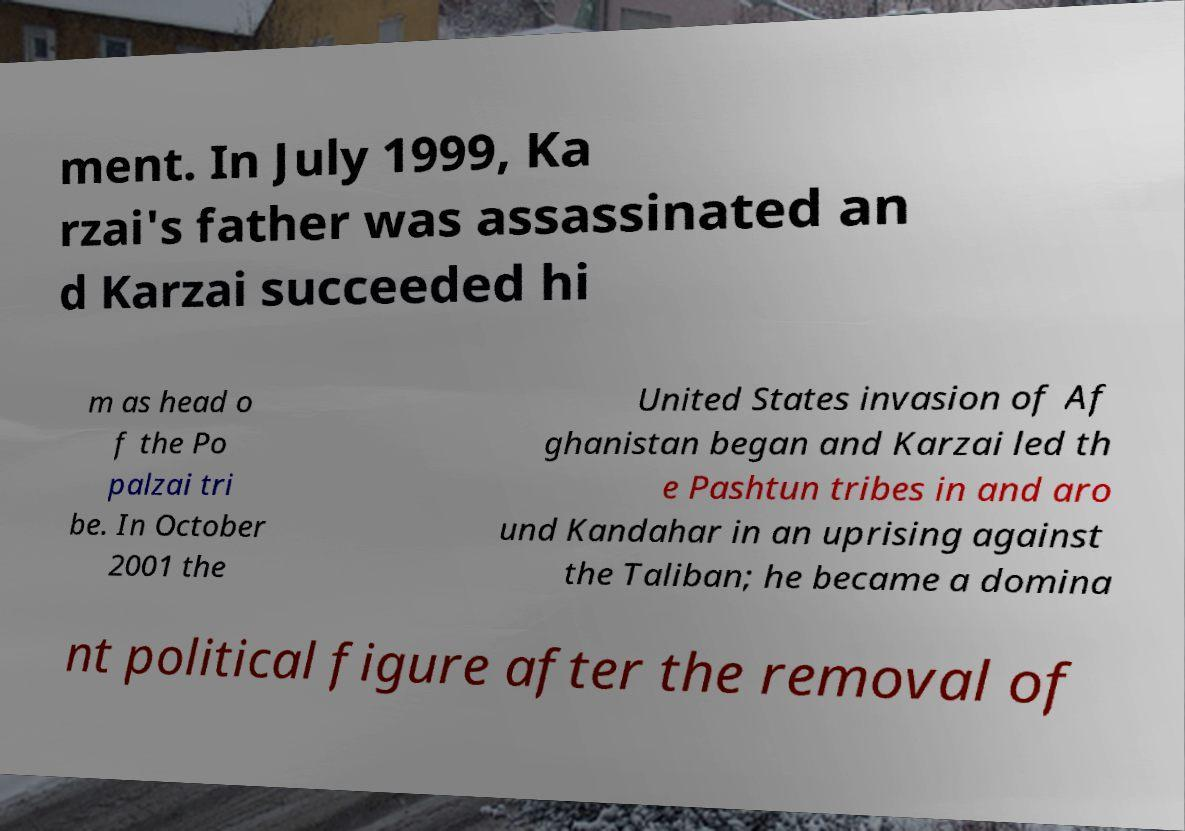Can you read and provide the text displayed in the image?This photo seems to have some interesting text. Can you extract and type it out for me? ment. In July 1999, Ka rzai's father was assassinated an d Karzai succeeded hi m as head o f the Po palzai tri be. In October 2001 the United States invasion of Af ghanistan began and Karzai led th e Pashtun tribes in and aro und Kandahar in an uprising against the Taliban; he became a domina nt political figure after the removal of 